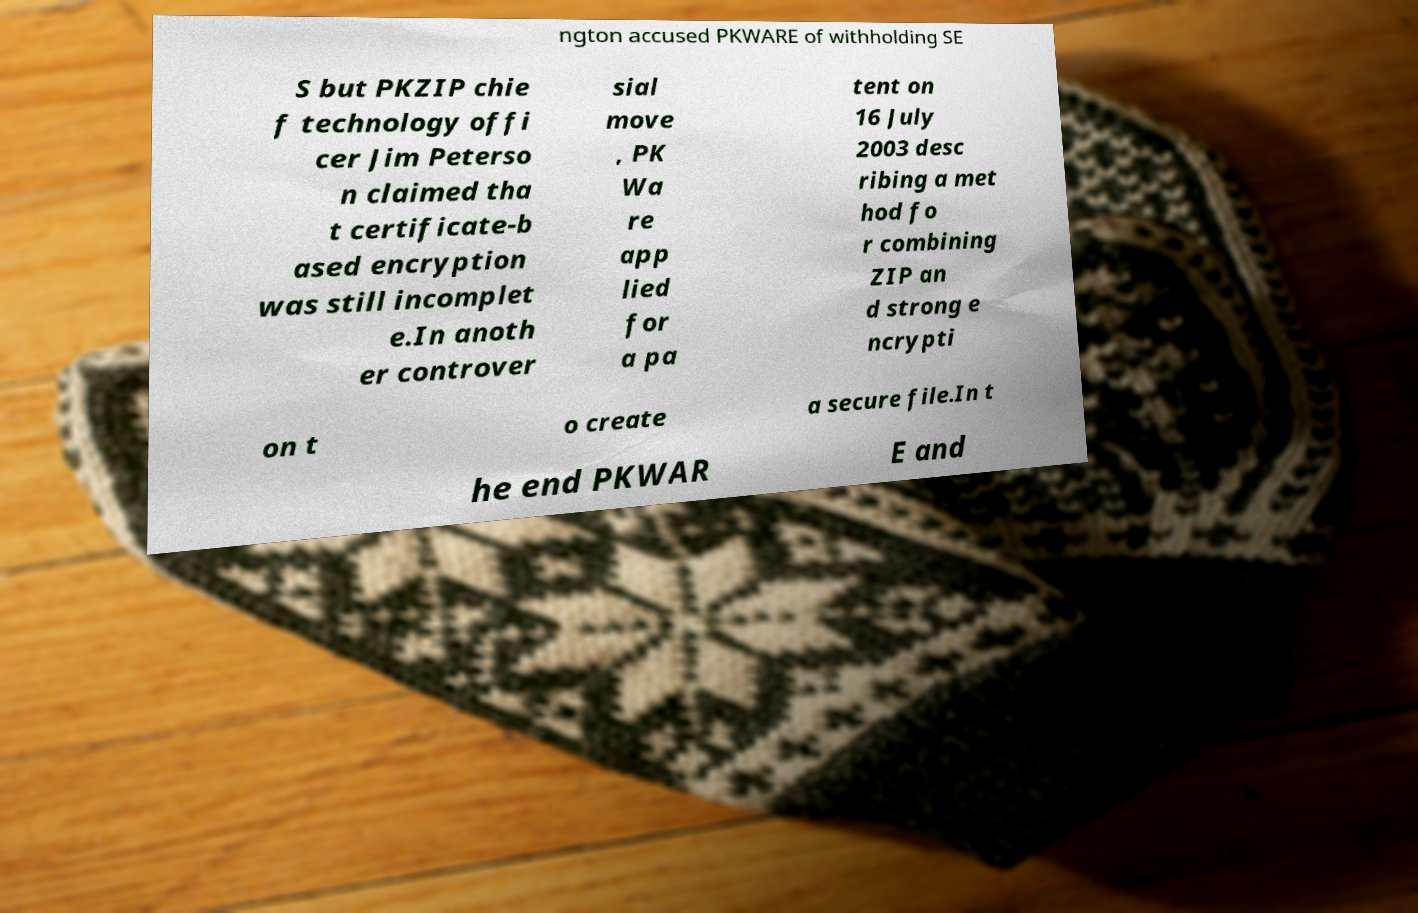Please identify and transcribe the text found in this image. ngton accused PKWARE of withholding SE S but PKZIP chie f technology offi cer Jim Peterso n claimed tha t certificate-b ased encryption was still incomplet e.In anoth er controver sial move , PK Wa re app lied for a pa tent on 16 July 2003 desc ribing a met hod fo r combining ZIP an d strong e ncrypti on t o create a secure file.In t he end PKWAR E and 